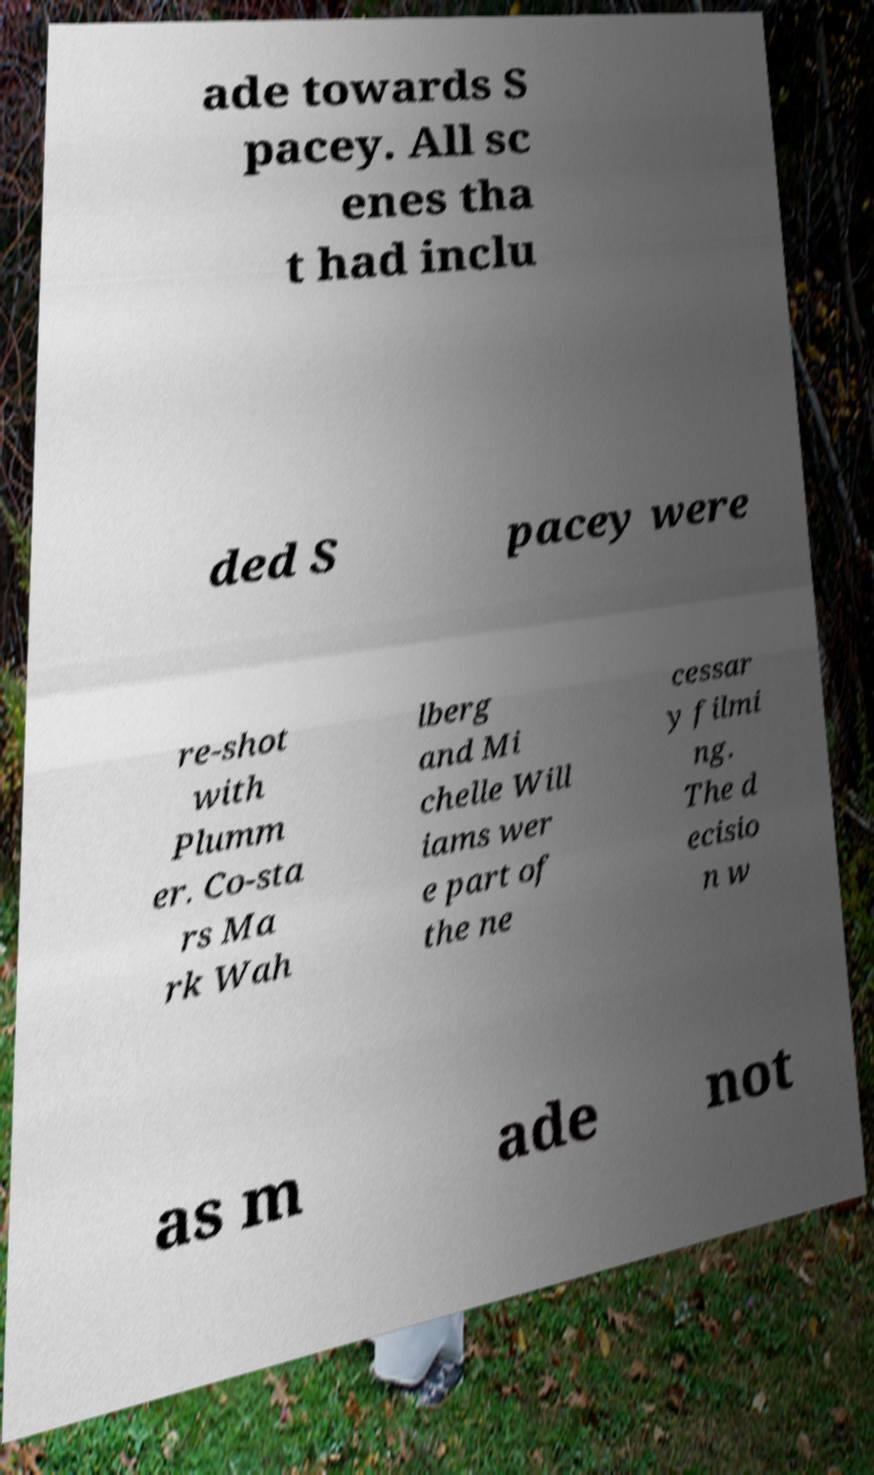Can you read and provide the text displayed in the image?This photo seems to have some interesting text. Can you extract and type it out for me? ade towards S pacey. All sc enes tha t had inclu ded S pacey were re-shot with Plumm er. Co-sta rs Ma rk Wah lberg and Mi chelle Will iams wer e part of the ne cessar y filmi ng. The d ecisio n w as m ade not 